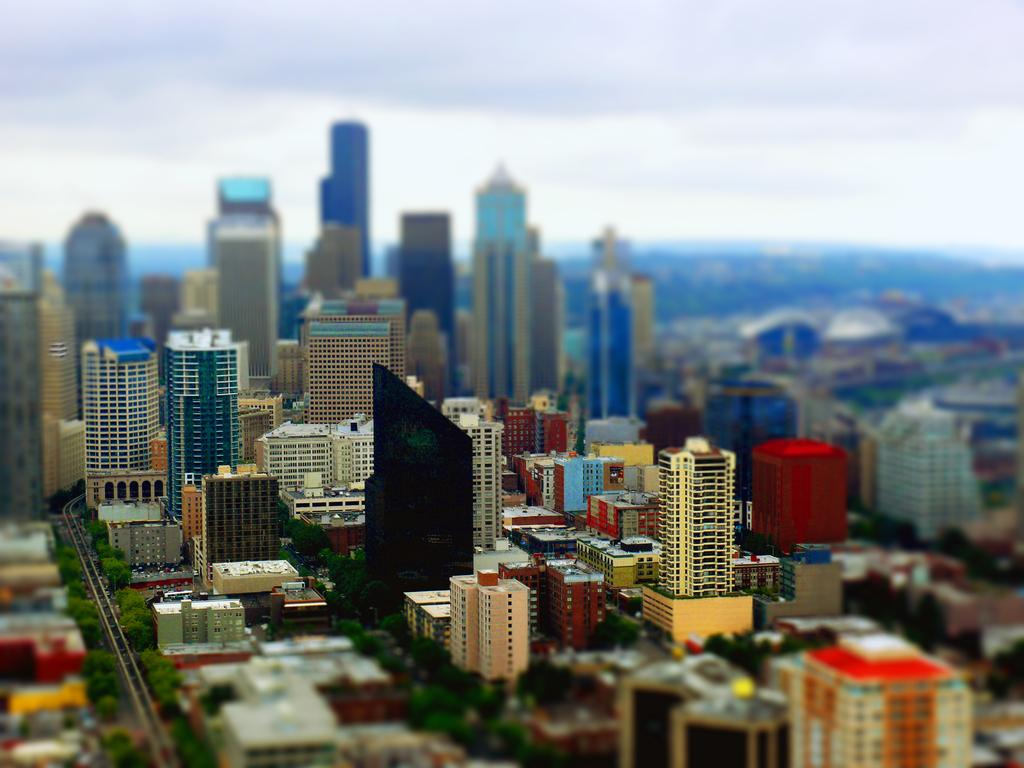What type of structures can be seen in the image? There are buildings in the image. What else can be seen in the image besides buildings? There are objects and trees in the image. Where are the buildings located in the image? Buildings are visible in the background of the image. What can be seen in the sky in the background of the image? Clouds are present in the sky in the background of the image. What type of waves can be seen crashing against the buildings in the image? There are no waves present in the image; it features buildings, objects, trees, and a sky with clouds. 